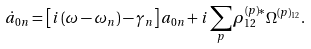Convert formula to latex. <formula><loc_0><loc_0><loc_500><loc_500>\dot { a } _ { 0 n } = \left [ i \left ( \omega - \omega _ { n } \right ) - \gamma _ { n } \right ] a _ { 0 n } + i \sum _ { p } \rho ^ { ( p ) \ast } _ { 1 2 } \Omega ^ { ( p ) _ { 1 2 } } .</formula> 